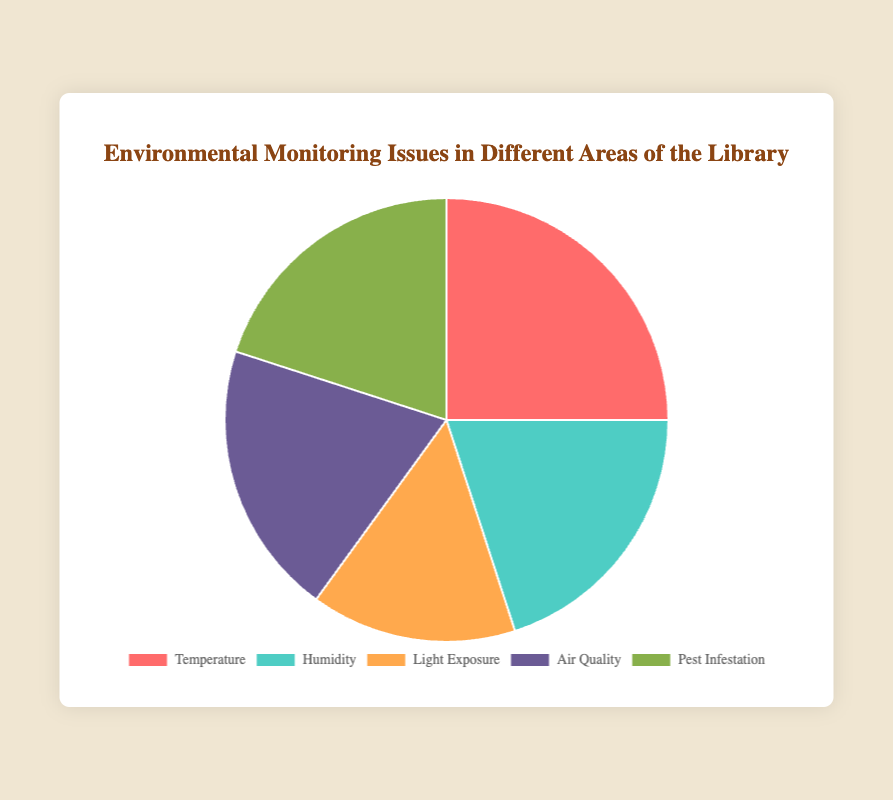What percentage of the library’s areas have Air Quality issues? Observing the Pie chart, the section for Air Quality demonstrates 20% of the total chart distribution.
Answer: 20% What is the combined percentage of the library areas dealing with Humidity and Pest Infestation issues? Adding the percentages for Humidity (20%) and Pest Infestation (20%) issues gives us 20% + 20% = 40%.
Answer: 40% Which two issue categories together surpass the percentage for Temperature issues? Comparing the percentages, Light Exposure (15%) and Air Quality (20%) together give 15% + 20% = 35%, which surpasses the Temperature issues at 25%.
Answer: Light Exposure and Air Quality Among Temperature, Humidity, and Pest Infestation, which issue categories have equal percentages? The Pie chart shows Humidity and Pest Infestation both have 20%, while Temperature has 25%.
Answer: Humidity and Pest Infestation Which issue area is least represented in the library’s environmental monitoring issues? The smallest segment on the Pie chart corresponds to Light Exposure, which is 15% of the total.
Answer: Light Exposure How does the portion of the Reading Room compare to the Manuscripts Section? The Reading Room, affected by Light Exposure (15%), has a smaller portion compared to the Manuscripts Section affected by Air Quality (20%).
Answer: Reading Room is less than Manuscripts Section What is the median percentage among the environmental issues presented? Listing the percentages in ascending order: 15%, 20%, 20%, 20%, 25%, the median value is the third number, which is 20%.
Answer: 20% If the percentage for Light Exposure issues doubled, what would the new total be? Doubling the Light Exposure percentage: 15% * 2 = 30%. Adding this to the current total (100% - 15% + 30%) gives 115%.
Answer: 115% Which environmental issue is equally affecting three different areas in the library? The Pie chart indicates that Humidity, Air Quality, and Pest Infestation each impact 20% of their respective areas, making their effect equal.
Answer: Humidity, Air Quality, and Pest Infestation What’s the percentage difference between the highest category and the lowest category? The highest category is Temperature (25%) and the lowest is Light Exposure (15%), the difference is 25% - 15% = 10%.
Answer: 10% 